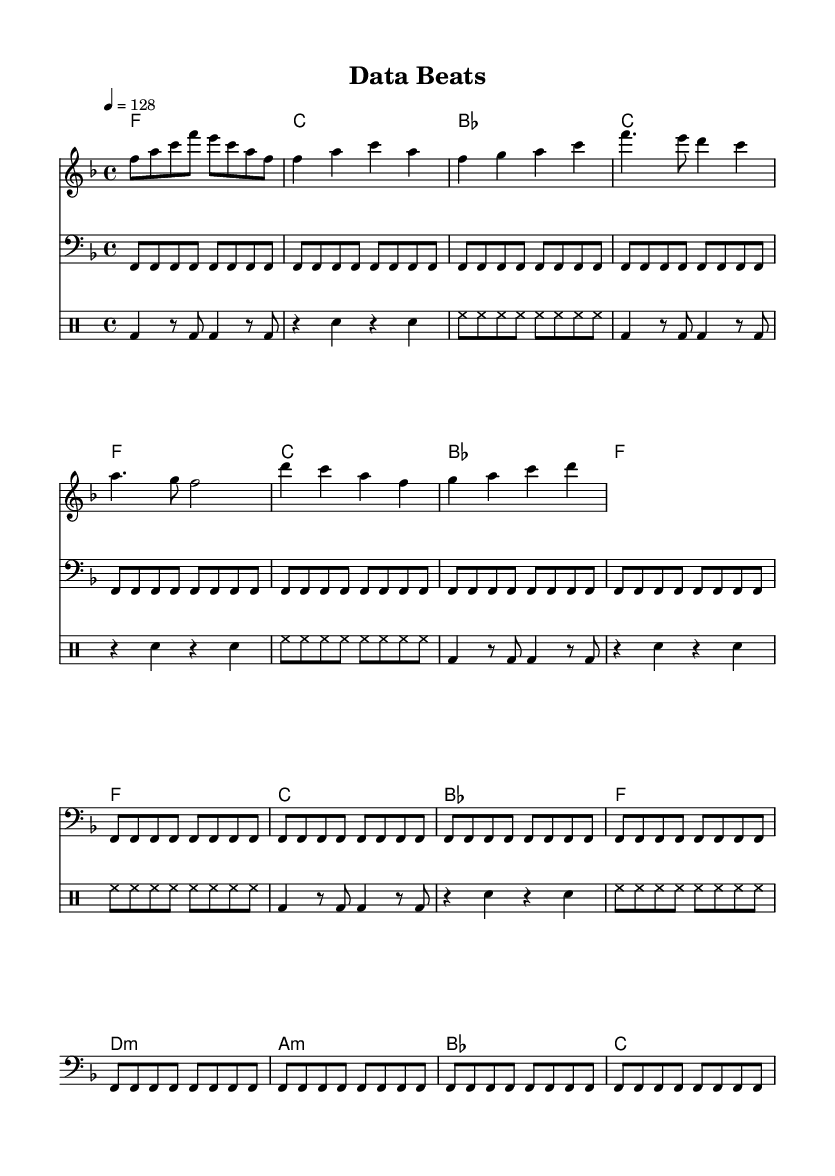What is the key signature of this music? The key signature is F major, which has one flat (B flat). You can identify the key signature in the beginning of the sheet music notation.
Answer: F major What is the time signature of the piece? The time signature is 4/4, meaning there are four beats per measure and the quarter note gets one beat. This is indicated at the beginning of the music.
Answer: 4/4 What is the tempo marking of the piece? The tempo marking is 128 beats per minute, noted above the staff. This indicates how fast the music should be played.
Answer: 128 How many measures are in the verse section? The verse consists of 4 measures, which is evident by counting the measures from the start of the verse section to the end.
Answer: 4 What is the lyrical theme of the chorus? The lyrical theme of the chorus revolves around data-driven success, emphasizing "data beats" and climbing metrics, which can be seen in the lyrics provided.
Answer: Data-driven success What instruments are included in this arrangement? The arrangement includes melody, bass, chords, and drums, as indicated by the different staves present in the sheet music. Each staff corresponds to a specific instrumental part.
Answer: Melody, bass, chords, drums What kind of musical genre does this sheet music represent? This sheet music represents the House genre, noted for its upbeat tempo and electronic elements, coupled with lyrics about data and success, which are characteristic of modern house tracks.
Answer: House 